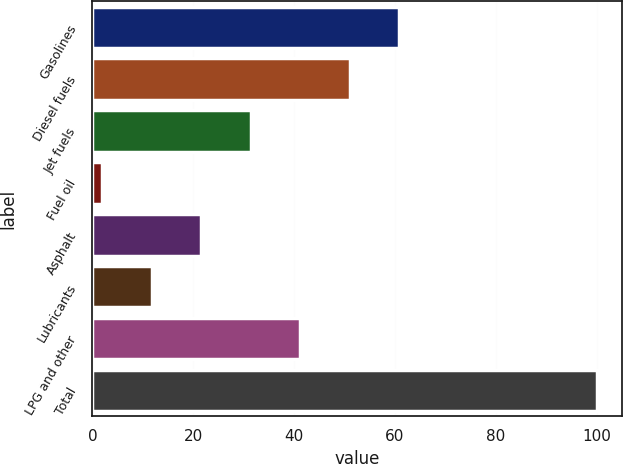<chart> <loc_0><loc_0><loc_500><loc_500><bar_chart><fcel>Gasolines<fcel>Diesel fuels<fcel>Jet fuels<fcel>Fuel oil<fcel>Asphalt<fcel>Lubricants<fcel>LPG and other<fcel>Total<nl><fcel>60.8<fcel>51<fcel>31.4<fcel>2<fcel>21.6<fcel>11.8<fcel>41.2<fcel>100<nl></chart> 